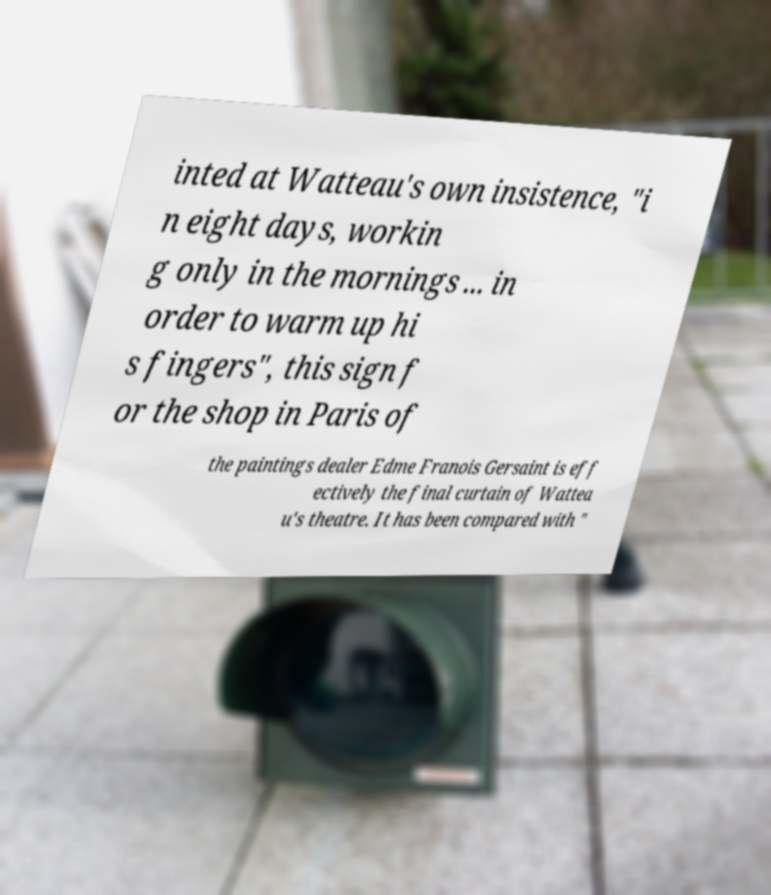Could you assist in decoding the text presented in this image and type it out clearly? inted at Watteau's own insistence, "i n eight days, workin g only in the mornings ... in order to warm up hi s fingers", this sign f or the shop in Paris of the paintings dealer Edme Franois Gersaint is eff ectively the final curtain of Wattea u's theatre. It has been compared with " 